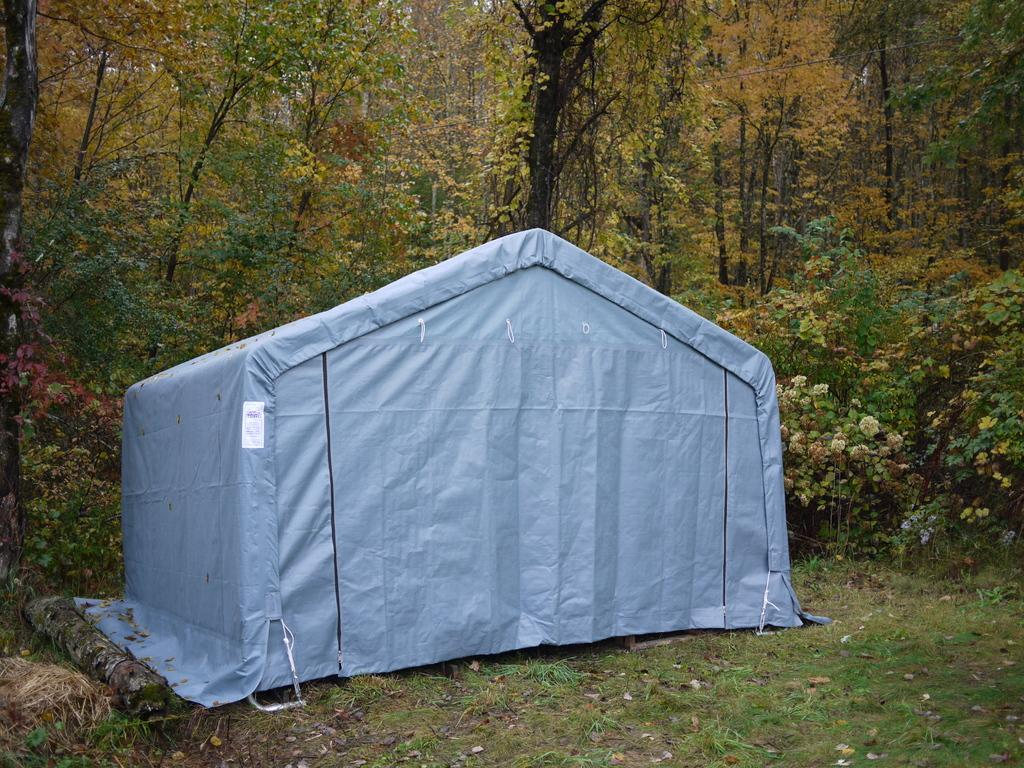What type of natural elements can be seen in the image? There are trees and plants in the image. What structure is located in the middle of the image? There is a tent in the middle of the image. What type of lumber is being used to construct the base of the tent in the image? There is no mention of lumber or a base for the tent in the image. The tent appears to be a freestanding structure without any visible support. 